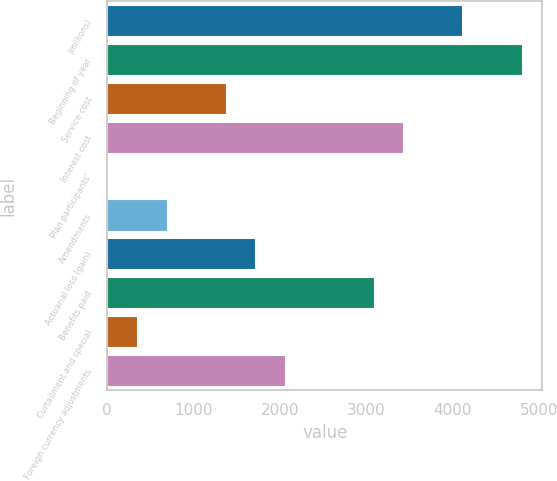Convert chart. <chart><loc_0><loc_0><loc_500><loc_500><bar_chart><fcel>(millions)<fcel>Beginning of year<fcel>Service cost<fcel>Interest cost<fcel>Plan participants'<fcel>Amendments<fcel>Actuarial loss (gain)<fcel>Benefits paid<fcel>Curtailment and special<fcel>Foreign currency adjustments<nl><fcel>4111.46<fcel>4796.42<fcel>1371.62<fcel>3426.5<fcel>1.7<fcel>686.66<fcel>1714.1<fcel>3084.02<fcel>344.18<fcel>2056.58<nl></chart> 